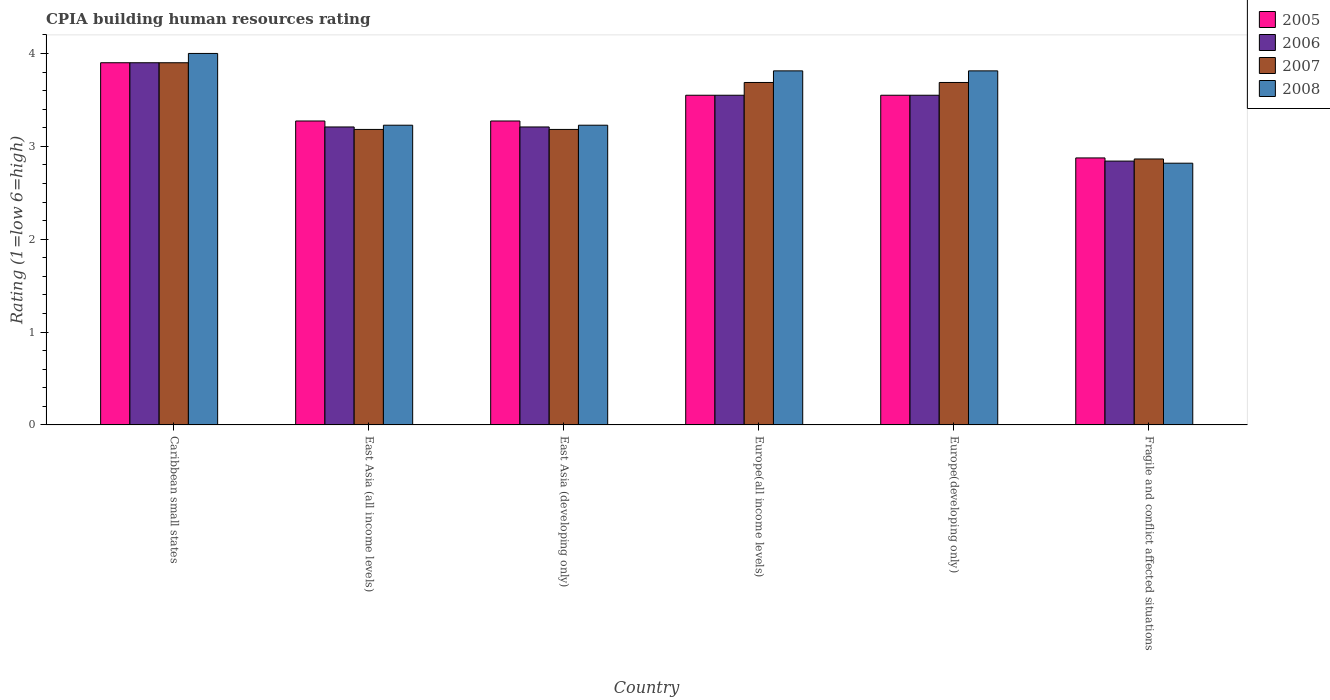Are the number of bars per tick equal to the number of legend labels?
Provide a succinct answer. Yes. Are the number of bars on each tick of the X-axis equal?
Provide a short and direct response. Yes. What is the label of the 6th group of bars from the left?
Give a very brief answer. Fragile and conflict affected situations. In how many cases, is the number of bars for a given country not equal to the number of legend labels?
Provide a succinct answer. 0. What is the CPIA rating in 2008 in Europe(all income levels)?
Offer a very short reply. 3.81. Across all countries, what is the minimum CPIA rating in 2005?
Make the answer very short. 2.88. In which country was the CPIA rating in 2008 maximum?
Provide a succinct answer. Caribbean small states. In which country was the CPIA rating in 2008 minimum?
Your answer should be very brief. Fragile and conflict affected situations. What is the total CPIA rating in 2006 in the graph?
Give a very brief answer. 20.26. What is the difference between the CPIA rating in 2007 in Europe(all income levels) and that in Europe(developing only)?
Your answer should be very brief. 0. What is the difference between the CPIA rating in 2006 in Europe(developing only) and the CPIA rating in 2008 in East Asia (developing only)?
Offer a terse response. 0.32. What is the average CPIA rating in 2007 per country?
Ensure brevity in your answer.  3.42. What is the difference between the CPIA rating of/in 2007 and CPIA rating of/in 2008 in Fragile and conflict affected situations?
Keep it short and to the point. 0.05. What is the ratio of the CPIA rating in 2008 in Caribbean small states to that in Fragile and conflict affected situations?
Give a very brief answer. 1.42. What is the difference between the highest and the second highest CPIA rating in 2007?
Provide a short and direct response. -0.21. What is the difference between the highest and the lowest CPIA rating in 2006?
Offer a terse response. 1.06. In how many countries, is the CPIA rating in 2007 greater than the average CPIA rating in 2007 taken over all countries?
Offer a terse response. 3. Is the sum of the CPIA rating in 2005 in Caribbean small states and Europe(all income levels) greater than the maximum CPIA rating in 2006 across all countries?
Your answer should be very brief. Yes. What does the 1st bar from the left in Europe(all income levels) represents?
Keep it short and to the point. 2005. Is it the case that in every country, the sum of the CPIA rating in 2006 and CPIA rating in 2008 is greater than the CPIA rating in 2005?
Make the answer very short. Yes. How many countries are there in the graph?
Give a very brief answer. 6. How are the legend labels stacked?
Your answer should be very brief. Vertical. What is the title of the graph?
Your response must be concise. CPIA building human resources rating. What is the label or title of the Y-axis?
Make the answer very short. Rating (1=low 6=high). What is the Rating (1=low 6=high) in 2005 in East Asia (all income levels)?
Make the answer very short. 3.27. What is the Rating (1=low 6=high) in 2006 in East Asia (all income levels)?
Your answer should be compact. 3.21. What is the Rating (1=low 6=high) of 2007 in East Asia (all income levels)?
Your response must be concise. 3.18. What is the Rating (1=low 6=high) of 2008 in East Asia (all income levels)?
Your answer should be compact. 3.23. What is the Rating (1=low 6=high) in 2005 in East Asia (developing only)?
Your answer should be compact. 3.27. What is the Rating (1=low 6=high) in 2006 in East Asia (developing only)?
Keep it short and to the point. 3.21. What is the Rating (1=low 6=high) of 2007 in East Asia (developing only)?
Ensure brevity in your answer.  3.18. What is the Rating (1=low 6=high) in 2008 in East Asia (developing only)?
Offer a very short reply. 3.23. What is the Rating (1=low 6=high) of 2005 in Europe(all income levels)?
Offer a terse response. 3.55. What is the Rating (1=low 6=high) of 2006 in Europe(all income levels)?
Provide a short and direct response. 3.55. What is the Rating (1=low 6=high) of 2007 in Europe(all income levels)?
Provide a succinct answer. 3.69. What is the Rating (1=low 6=high) of 2008 in Europe(all income levels)?
Provide a succinct answer. 3.81. What is the Rating (1=low 6=high) of 2005 in Europe(developing only)?
Give a very brief answer. 3.55. What is the Rating (1=low 6=high) in 2006 in Europe(developing only)?
Offer a terse response. 3.55. What is the Rating (1=low 6=high) of 2007 in Europe(developing only)?
Your answer should be compact. 3.69. What is the Rating (1=low 6=high) of 2008 in Europe(developing only)?
Your answer should be compact. 3.81. What is the Rating (1=low 6=high) of 2005 in Fragile and conflict affected situations?
Keep it short and to the point. 2.88. What is the Rating (1=low 6=high) in 2006 in Fragile and conflict affected situations?
Offer a very short reply. 2.84. What is the Rating (1=low 6=high) of 2007 in Fragile and conflict affected situations?
Your response must be concise. 2.86. What is the Rating (1=low 6=high) of 2008 in Fragile and conflict affected situations?
Your answer should be compact. 2.82. Across all countries, what is the maximum Rating (1=low 6=high) of 2008?
Provide a succinct answer. 4. Across all countries, what is the minimum Rating (1=low 6=high) of 2005?
Give a very brief answer. 2.88. Across all countries, what is the minimum Rating (1=low 6=high) of 2006?
Your response must be concise. 2.84. Across all countries, what is the minimum Rating (1=low 6=high) of 2007?
Offer a terse response. 2.86. Across all countries, what is the minimum Rating (1=low 6=high) of 2008?
Ensure brevity in your answer.  2.82. What is the total Rating (1=low 6=high) in 2005 in the graph?
Ensure brevity in your answer.  20.42. What is the total Rating (1=low 6=high) of 2006 in the graph?
Ensure brevity in your answer.  20.26. What is the total Rating (1=low 6=high) of 2007 in the graph?
Offer a terse response. 20.5. What is the total Rating (1=low 6=high) of 2008 in the graph?
Keep it short and to the point. 20.9. What is the difference between the Rating (1=low 6=high) in 2005 in Caribbean small states and that in East Asia (all income levels)?
Make the answer very short. 0.63. What is the difference between the Rating (1=low 6=high) of 2006 in Caribbean small states and that in East Asia (all income levels)?
Offer a very short reply. 0.69. What is the difference between the Rating (1=low 6=high) in 2007 in Caribbean small states and that in East Asia (all income levels)?
Keep it short and to the point. 0.72. What is the difference between the Rating (1=low 6=high) in 2008 in Caribbean small states and that in East Asia (all income levels)?
Make the answer very short. 0.77. What is the difference between the Rating (1=low 6=high) in 2005 in Caribbean small states and that in East Asia (developing only)?
Keep it short and to the point. 0.63. What is the difference between the Rating (1=low 6=high) in 2006 in Caribbean small states and that in East Asia (developing only)?
Your answer should be compact. 0.69. What is the difference between the Rating (1=low 6=high) in 2007 in Caribbean small states and that in East Asia (developing only)?
Ensure brevity in your answer.  0.72. What is the difference between the Rating (1=low 6=high) in 2008 in Caribbean small states and that in East Asia (developing only)?
Give a very brief answer. 0.77. What is the difference between the Rating (1=low 6=high) in 2007 in Caribbean small states and that in Europe(all income levels)?
Your answer should be compact. 0.21. What is the difference between the Rating (1=low 6=high) of 2008 in Caribbean small states and that in Europe(all income levels)?
Make the answer very short. 0.19. What is the difference between the Rating (1=low 6=high) of 2007 in Caribbean small states and that in Europe(developing only)?
Offer a terse response. 0.21. What is the difference between the Rating (1=low 6=high) of 2008 in Caribbean small states and that in Europe(developing only)?
Offer a very short reply. 0.19. What is the difference between the Rating (1=low 6=high) of 2006 in Caribbean small states and that in Fragile and conflict affected situations?
Offer a terse response. 1.06. What is the difference between the Rating (1=low 6=high) of 2007 in Caribbean small states and that in Fragile and conflict affected situations?
Provide a short and direct response. 1.04. What is the difference between the Rating (1=low 6=high) in 2008 in Caribbean small states and that in Fragile and conflict affected situations?
Provide a short and direct response. 1.18. What is the difference between the Rating (1=low 6=high) in 2005 in East Asia (all income levels) and that in East Asia (developing only)?
Your answer should be very brief. 0. What is the difference between the Rating (1=low 6=high) in 2006 in East Asia (all income levels) and that in East Asia (developing only)?
Your answer should be compact. 0. What is the difference between the Rating (1=low 6=high) of 2007 in East Asia (all income levels) and that in East Asia (developing only)?
Provide a succinct answer. 0. What is the difference between the Rating (1=low 6=high) in 2008 in East Asia (all income levels) and that in East Asia (developing only)?
Make the answer very short. 0. What is the difference between the Rating (1=low 6=high) in 2005 in East Asia (all income levels) and that in Europe(all income levels)?
Offer a very short reply. -0.28. What is the difference between the Rating (1=low 6=high) in 2006 in East Asia (all income levels) and that in Europe(all income levels)?
Keep it short and to the point. -0.34. What is the difference between the Rating (1=low 6=high) in 2007 in East Asia (all income levels) and that in Europe(all income levels)?
Offer a terse response. -0.51. What is the difference between the Rating (1=low 6=high) of 2008 in East Asia (all income levels) and that in Europe(all income levels)?
Provide a short and direct response. -0.59. What is the difference between the Rating (1=low 6=high) of 2005 in East Asia (all income levels) and that in Europe(developing only)?
Your answer should be compact. -0.28. What is the difference between the Rating (1=low 6=high) of 2006 in East Asia (all income levels) and that in Europe(developing only)?
Ensure brevity in your answer.  -0.34. What is the difference between the Rating (1=low 6=high) of 2007 in East Asia (all income levels) and that in Europe(developing only)?
Your answer should be very brief. -0.51. What is the difference between the Rating (1=low 6=high) of 2008 in East Asia (all income levels) and that in Europe(developing only)?
Provide a succinct answer. -0.59. What is the difference between the Rating (1=low 6=high) of 2005 in East Asia (all income levels) and that in Fragile and conflict affected situations?
Offer a terse response. 0.4. What is the difference between the Rating (1=low 6=high) in 2006 in East Asia (all income levels) and that in Fragile and conflict affected situations?
Give a very brief answer. 0.37. What is the difference between the Rating (1=low 6=high) of 2007 in East Asia (all income levels) and that in Fragile and conflict affected situations?
Make the answer very short. 0.32. What is the difference between the Rating (1=low 6=high) in 2008 in East Asia (all income levels) and that in Fragile and conflict affected situations?
Ensure brevity in your answer.  0.41. What is the difference between the Rating (1=low 6=high) of 2005 in East Asia (developing only) and that in Europe(all income levels)?
Offer a terse response. -0.28. What is the difference between the Rating (1=low 6=high) in 2006 in East Asia (developing only) and that in Europe(all income levels)?
Offer a terse response. -0.34. What is the difference between the Rating (1=low 6=high) in 2007 in East Asia (developing only) and that in Europe(all income levels)?
Keep it short and to the point. -0.51. What is the difference between the Rating (1=low 6=high) in 2008 in East Asia (developing only) and that in Europe(all income levels)?
Your response must be concise. -0.59. What is the difference between the Rating (1=low 6=high) of 2005 in East Asia (developing only) and that in Europe(developing only)?
Give a very brief answer. -0.28. What is the difference between the Rating (1=low 6=high) in 2006 in East Asia (developing only) and that in Europe(developing only)?
Your answer should be very brief. -0.34. What is the difference between the Rating (1=low 6=high) in 2007 in East Asia (developing only) and that in Europe(developing only)?
Make the answer very short. -0.51. What is the difference between the Rating (1=low 6=high) of 2008 in East Asia (developing only) and that in Europe(developing only)?
Give a very brief answer. -0.59. What is the difference between the Rating (1=low 6=high) of 2005 in East Asia (developing only) and that in Fragile and conflict affected situations?
Provide a short and direct response. 0.4. What is the difference between the Rating (1=low 6=high) in 2006 in East Asia (developing only) and that in Fragile and conflict affected situations?
Your answer should be compact. 0.37. What is the difference between the Rating (1=low 6=high) in 2007 in East Asia (developing only) and that in Fragile and conflict affected situations?
Your response must be concise. 0.32. What is the difference between the Rating (1=low 6=high) in 2008 in East Asia (developing only) and that in Fragile and conflict affected situations?
Ensure brevity in your answer.  0.41. What is the difference between the Rating (1=low 6=high) of 2005 in Europe(all income levels) and that in Fragile and conflict affected situations?
Provide a succinct answer. 0.68. What is the difference between the Rating (1=low 6=high) in 2006 in Europe(all income levels) and that in Fragile and conflict affected situations?
Ensure brevity in your answer.  0.71. What is the difference between the Rating (1=low 6=high) of 2007 in Europe(all income levels) and that in Fragile and conflict affected situations?
Ensure brevity in your answer.  0.82. What is the difference between the Rating (1=low 6=high) in 2005 in Europe(developing only) and that in Fragile and conflict affected situations?
Ensure brevity in your answer.  0.68. What is the difference between the Rating (1=low 6=high) in 2006 in Europe(developing only) and that in Fragile and conflict affected situations?
Your answer should be compact. 0.71. What is the difference between the Rating (1=low 6=high) of 2007 in Europe(developing only) and that in Fragile and conflict affected situations?
Make the answer very short. 0.82. What is the difference between the Rating (1=low 6=high) of 2008 in Europe(developing only) and that in Fragile and conflict affected situations?
Make the answer very short. 0.99. What is the difference between the Rating (1=low 6=high) in 2005 in Caribbean small states and the Rating (1=low 6=high) in 2006 in East Asia (all income levels)?
Ensure brevity in your answer.  0.69. What is the difference between the Rating (1=low 6=high) of 2005 in Caribbean small states and the Rating (1=low 6=high) of 2007 in East Asia (all income levels)?
Ensure brevity in your answer.  0.72. What is the difference between the Rating (1=low 6=high) in 2005 in Caribbean small states and the Rating (1=low 6=high) in 2008 in East Asia (all income levels)?
Provide a succinct answer. 0.67. What is the difference between the Rating (1=low 6=high) of 2006 in Caribbean small states and the Rating (1=low 6=high) of 2007 in East Asia (all income levels)?
Offer a terse response. 0.72. What is the difference between the Rating (1=low 6=high) in 2006 in Caribbean small states and the Rating (1=low 6=high) in 2008 in East Asia (all income levels)?
Offer a terse response. 0.67. What is the difference between the Rating (1=low 6=high) of 2007 in Caribbean small states and the Rating (1=low 6=high) of 2008 in East Asia (all income levels)?
Ensure brevity in your answer.  0.67. What is the difference between the Rating (1=low 6=high) in 2005 in Caribbean small states and the Rating (1=low 6=high) in 2006 in East Asia (developing only)?
Ensure brevity in your answer.  0.69. What is the difference between the Rating (1=low 6=high) of 2005 in Caribbean small states and the Rating (1=low 6=high) of 2007 in East Asia (developing only)?
Provide a succinct answer. 0.72. What is the difference between the Rating (1=low 6=high) in 2005 in Caribbean small states and the Rating (1=low 6=high) in 2008 in East Asia (developing only)?
Give a very brief answer. 0.67. What is the difference between the Rating (1=low 6=high) in 2006 in Caribbean small states and the Rating (1=low 6=high) in 2007 in East Asia (developing only)?
Make the answer very short. 0.72. What is the difference between the Rating (1=low 6=high) in 2006 in Caribbean small states and the Rating (1=low 6=high) in 2008 in East Asia (developing only)?
Offer a very short reply. 0.67. What is the difference between the Rating (1=low 6=high) in 2007 in Caribbean small states and the Rating (1=low 6=high) in 2008 in East Asia (developing only)?
Your answer should be compact. 0.67. What is the difference between the Rating (1=low 6=high) of 2005 in Caribbean small states and the Rating (1=low 6=high) of 2006 in Europe(all income levels)?
Make the answer very short. 0.35. What is the difference between the Rating (1=low 6=high) of 2005 in Caribbean small states and the Rating (1=low 6=high) of 2007 in Europe(all income levels)?
Keep it short and to the point. 0.21. What is the difference between the Rating (1=low 6=high) of 2005 in Caribbean small states and the Rating (1=low 6=high) of 2008 in Europe(all income levels)?
Provide a short and direct response. 0.09. What is the difference between the Rating (1=low 6=high) in 2006 in Caribbean small states and the Rating (1=low 6=high) in 2007 in Europe(all income levels)?
Provide a succinct answer. 0.21. What is the difference between the Rating (1=low 6=high) in 2006 in Caribbean small states and the Rating (1=low 6=high) in 2008 in Europe(all income levels)?
Your response must be concise. 0.09. What is the difference between the Rating (1=low 6=high) of 2007 in Caribbean small states and the Rating (1=low 6=high) of 2008 in Europe(all income levels)?
Keep it short and to the point. 0.09. What is the difference between the Rating (1=low 6=high) of 2005 in Caribbean small states and the Rating (1=low 6=high) of 2006 in Europe(developing only)?
Make the answer very short. 0.35. What is the difference between the Rating (1=low 6=high) in 2005 in Caribbean small states and the Rating (1=low 6=high) in 2007 in Europe(developing only)?
Keep it short and to the point. 0.21. What is the difference between the Rating (1=low 6=high) in 2005 in Caribbean small states and the Rating (1=low 6=high) in 2008 in Europe(developing only)?
Offer a very short reply. 0.09. What is the difference between the Rating (1=low 6=high) in 2006 in Caribbean small states and the Rating (1=low 6=high) in 2007 in Europe(developing only)?
Your response must be concise. 0.21. What is the difference between the Rating (1=low 6=high) of 2006 in Caribbean small states and the Rating (1=low 6=high) of 2008 in Europe(developing only)?
Your answer should be very brief. 0.09. What is the difference between the Rating (1=low 6=high) in 2007 in Caribbean small states and the Rating (1=low 6=high) in 2008 in Europe(developing only)?
Ensure brevity in your answer.  0.09. What is the difference between the Rating (1=low 6=high) in 2005 in Caribbean small states and the Rating (1=low 6=high) in 2006 in Fragile and conflict affected situations?
Provide a short and direct response. 1.06. What is the difference between the Rating (1=low 6=high) in 2005 in Caribbean small states and the Rating (1=low 6=high) in 2007 in Fragile and conflict affected situations?
Provide a short and direct response. 1.04. What is the difference between the Rating (1=low 6=high) of 2005 in Caribbean small states and the Rating (1=low 6=high) of 2008 in Fragile and conflict affected situations?
Offer a very short reply. 1.08. What is the difference between the Rating (1=low 6=high) in 2006 in Caribbean small states and the Rating (1=low 6=high) in 2007 in Fragile and conflict affected situations?
Give a very brief answer. 1.04. What is the difference between the Rating (1=low 6=high) of 2006 in Caribbean small states and the Rating (1=low 6=high) of 2008 in Fragile and conflict affected situations?
Make the answer very short. 1.08. What is the difference between the Rating (1=low 6=high) of 2007 in Caribbean small states and the Rating (1=low 6=high) of 2008 in Fragile and conflict affected situations?
Your response must be concise. 1.08. What is the difference between the Rating (1=low 6=high) of 2005 in East Asia (all income levels) and the Rating (1=low 6=high) of 2006 in East Asia (developing only)?
Keep it short and to the point. 0.06. What is the difference between the Rating (1=low 6=high) in 2005 in East Asia (all income levels) and the Rating (1=low 6=high) in 2007 in East Asia (developing only)?
Your response must be concise. 0.09. What is the difference between the Rating (1=low 6=high) of 2005 in East Asia (all income levels) and the Rating (1=low 6=high) of 2008 in East Asia (developing only)?
Give a very brief answer. 0.05. What is the difference between the Rating (1=low 6=high) in 2006 in East Asia (all income levels) and the Rating (1=low 6=high) in 2007 in East Asia (developing only)?
Ensure brevity in your answer.  0.03. What is the difference between the Rating (1=low 6=high) of 2006 in East Asia (all income levels) and the Rating (1=low 6=high) of 2008 in East Asia (developing only)?
Give a very brief answer. -0.02. What is the difference between the Rating (1=low 6=high) of 2007 in East Asia (all income levels) and the Rating (1=low 6=high) of 2008 in East Asia (developing only)?
Ensure brevity in your answer.  -0.05. What is the difference between the Rating (1=low 6=high) of 2005 in East Asia (all income levels) and the Rating (1=low 6=high) of 2006 in Europe(all income levels)?
Provide a succinct answer. -0.28. What is the difference between the Rating (1=low 6=high) in 2005 in East Asia (all income levels) and the Rating (1=low 6=high) in 2007 in Europe(all income levels)?
Provide a short and direct response. -0.41. What is the difference between the Rating (1=low 6=high) of 2005 in East Asia (all income levels) and the Rating (1=low 6=high) of 2008 in Europe(all income levels)?
Offer a terse response. -0.54. What is the difference between the Rating (1=low 6=high) of 2006 in East Asia (all income levels) and the Rating (1=low 6=high) of 2007 in Europe(all income levels)?
Keep it short and to the point. -0.48. What is the difference between the Rating (1=low 6=high) of 2006 in East Asia (all income levels) and the Rating (1=low 6=high) of 2008 in Europe(all income levels)?
Your response must be concise. -0.6. What is the difference between the Rating (1=low 6=high) in 2007 in East Asia (all income levels) and the Rating (1=low 6=high) in 2008 in Europe(all income levels)?
Keep it short and to the point. -0.63. What is the difference between the Rating (1=low 6=high) in 2005 in East Asia (all income levels) and the Rating (1=low 6=high) in 2006 in Europe(developing only)?
Provide a succinct answer. -0.28. What is the difference between the Rating (1=low 6=high) of 2005 in East Asia (all income levels) and the Rating (1=low 6=high) of 2007 in Europe(developing only)?
Give a very brief answer. -0.41. What is the difference between the Rating (1=low 6=high) of 2005 in East Asia (all income levels) and the Rating (1=low 6=high) of 2008 in Europe(developing only)?
Your answer should be compact. -0.54. What is the difference between the Rating (1=low 6=high) in 2006 in East Asia (all income levels) and the Rating (1=low 6=high) in 2007 in Europe(developing only)?
Provide a succinct answer. -0.48. What is the difference between the Rating (1=low 6=high) of 2006 in East Asia (all income levels) and the Rating (1=low 6=high) of 2008 in Europe(developing only)?
Keep it short and to the point. -0.6. What is the difference between the Rating (1=low 6=high) in 2007 in East Asia (all income levels) and the Rating (1=low 6=high) in 2008 in Europe(developing only)?
Ensure brevity in your answer.  -0.63. What is the difference between the Rating (1=low 6=high) in 2005 in East Asia (all income levels) and the Rating (1=low 6=high) in 2006 in Fragile and conflict affected situations?
Make the answer very short. 0.43. What is the difference between the Rating (1=low 6=high) in 2005 in East Asia (all income levels) and the Rating (1=low 6=high) in 2007 in Fragile and conflict affected situations?
Provide a succinct answer. 0.41. What is the difference between the Rating (1=low 6=high) in 2005 in East Asia (all income levels) and the Rating (1=low 6=high) in 2008 in Fragile and conflict affected situations?
Give a very brief answer. 0.45. What is the difference between the Rating (1=low 6=high) in 2006 in East Asia (all income levels) and the Rating (1=low 6=high) in 2007 in Fragile and conflict affected situations?
Ensure brevity in your answer.  0.34. What is the difference between the Rating (1=low 6=high) in 2006 in East Asia (all income levels) and the Rating (1=low 6=high) in 2008 in Fragile and conflict affected situations?
Offer a terse response. 0.39. What is the difference between the Rating (1=low 6=high) of 2007 in East Asia (all income levels) and the Rating (1=low 6=high) of 2008 in Fragile and conflict affected situations?
Your response must be concise. 0.36. What is the difference between the Rating (1=low 6=high) of 2005 in East Asia (developing only) and the Rating (1=low 6=high) of 2006 in Europe(all income levels)?
Provide a short and direct response. -0.28. What is the difference between the Rating (1=low 6=high) of 2005 in East Asia (developing only) and the Rating (1=low 6=high) of 2007 in Europe(all income levels)?
Your answer should be compact. -0.41. What is the difference between the Rating (1=low 6=high) in 2005 in East Asia (developing only) and the Rating (1=low 6=high) in 2008 in Europe(all income levels)?
Give a very brief answer. -0.54. What is the difference between the Rating (1=low 6=high) in 2006 in East Asia (developing only) and the Rating (1=low 6=high) in 2007 in Europe(all income levels)?
Your answer should be very brief. -0.48. What is the difference between the Rating (1=low 6=high) in 2006 in East Asia (developing only) and the Rating (1=low 6=high) in 2008 in Europe(all income levels)?
Ensure brevity in your answer.  -0.6. What is the difference between the Rating (1=low 6=high) of 2007 in East Asia (developing only) and the Rating (1=low 6=high) of 2008 in Europe(all income levels)?
Provide a succinct answer. -0.63. What is the difference between the Rating (1=low 6=high) in 2005 in East Asia (developing only) and the Rating (1=low 6=high) in 2006 in Europe(developing only)?
Your answer should be very brief. -0.28. What is the difference between the Rating (1=low 6=high) of 2005 in East Asia (developing only) and the Rating (1=low 6=high) of 2007 in Europe(developing only)?
Provide a short and direct response. -0.41. What is the difference between the Rating (1=low 6=high) of 2005 in East Asia (developing only) and the Rating (1=low 6=high) of 2008 in Europe(developing only)?
Make the answer very short. -0.54. What is the difference between the Rating (1=low 6=high) in 2006 in East Asia (developing only) and the Rating (1=low 6=high) in 2007 in Europe(developing only)?
Offer a very short reply. -0.48. What is the difference between the Rating (1=low 6=high) of 2006 in East Asia (developing only) and the Rating (1=low 6=high) of 2008 in Europe(developing only)?
Provide a short and direct response. -0.6. What is the difference between the Rating (1=low 6=high) of 2007 in East Asia (developing only) and the Rating (1=low 6=high) of 2008 in Europe(developing only)?
Offer a very short reply. -0.63. What is the difference between the Rating (1=low 6=high) in 2005 in East Asia (developing only) and the Rating (1=low 6=high) in 2006 in Fragile and conflict affected situations?
Your answer should be compact. 0.43. What is the difference between the Rating (1=low 6=high) of 2005 in East Asia (developing only) and the Rating (1=low 6=high) of 2007 in Fragile and conflict affected situations?
Provide a short and direct response. 0.41. What is the difference between the Rating (1=low 6=high) of 2005 in East Asia (developing only) and the Rating (1=low 6=high) of 2008 in Fragile and conflict affected situations?
Your answer should be compact. 0.45. What is the difference between the Rating (1=low 6=high) in 2006 in East Asia (developing only) and the Rating (1=low 6=high) in 2007 in Fragile and conflict affected situations?
Keep it short and to the point. 0.34. What is the difference between the Rating (1=low 6=high) of 2006 in East Asia (developing only) and the Rating (1=low 6=high) of 2008 in Fragile and conflict affected situations?
Your answer should be compact. 0.39. What is the difference between the Rating (1=low 6=high) of 2007 in East Asia (developing only) and the Rating (1=low 6=high) of 2008 in Fragile and conflict affected situations?
Make the answer very short. 0.36. What is the difference between the Rating (1=low 6=high) of 2005 in Europe(all income levels) and the Rating (1=low 6=high) of 2007 in Europe(developing only)?
Ensure brevity in your answer.  -0.14. What is the difference between the Rating (1=low 6=high) in 2005 in Europe(all income levels) and the Rating (1=low 6=high) in 2008 in Europe(developing only)?
Offer a terse response. -0.26. What is the difference between the Rating (1=low 6=high) of 2006 in Europe(all income levels) and the Rating (1=low 6=high) of 2007 in Europe(developing only)?
Make the answer very short. -0.14. What is the difference between the Rating (1=low 6=high) in 2006 in Europe(all income levels) and the Rating (1=low 6=high) in 2008 in Europe(developing only)?
Keep it short and to the point. -0.26. What is the difference between the Rating (1=low 6=high) in 2007 in Europe(all income levels) and the Rating (1=low 6=high) in 2008 in Europe(developing only)?
Keep it short and to the point. -0.12. What is the difference between the Rating (1=low 6=high) in 2005 in Europe(all income levels) and the Rating (1=low 6=high) in 2006 in Fragile and conflict affected situations?
Make the answer very short. 0.71. What is the difference between the Rating (1=low 6=high) of 2005 in Europe(all income levels) and the Rating (1=low 6=high) of 2007 in Fragile and conflict affected situations?
Give a very brief answer. 0.69. What is the difference between the Rating (1=low 6=high) in 2005 in Europe(all income levels) and the Rating (1=low 6=high) in 2008 in Fragile and conflict affected situations?
Give a very brief answer. 0.73. What is the difference between the Rating (1=low 6=high) in 2006 in Europe(all income levels) and the Rating (1=low 6=high) in 2007 in Fragile and conflict affected situations?
Offer a terse response. 0.69. What is the difference between the Rating (1=low 6=high) of 2006 in Europe(all income levels) and the Rating (1=low 6=high) of 2008 in Fragile and conflict affected situations?
Give a very brief answer. 0.73. What is the difference between the Rating (1=low 6=high) in 2007 in Europe(all income levels) and the Rating (1=low 6=high) in 2008 in Fragile and conflict affected situations?
Make the answer very short. 0.87. What is the difference between the Rating (1=low 6=high) in 2005 in Europe(developing only) and the Rating (1=low 6=high) in 2006 in Fragile and conflict affected situations?
Ensure brevity in your answer.  0.71. What is the difference between the Rating (1=low 6=high) of 2005 in Europe(developing only) and the Rating (1=low 6=high) of 2007 in Fragile and conflict affected situations?
Ensure brevity in your answer.  0.69. What is the difference between the Rating (1=low 6=high) in 2005 in Europe(developing only) and the Rating (1=low 6=high) in 2008 in Fragile and conflict affected situations?
Keep it short and to the point. 0.73. What is the difference between the Rating (1=low 6=high) in 2006 in Europe(developing only) and the Rating (1=low 6=high) in 2007 in Fragile and conflict affected situations?
Provide a short and direct response. 0.69. What is the difference between the Rating (1=low 6=high) of 2006 in Europe(developing only) and the Rating (1=low 6=high) of 2008 in Fragile and conflict affected situations?
Give a very brief answer. 0.73. What is the difference between the Rating (1=low 6=high) in 2007 in Europe(developing only) and the Rating (1=low 6=high) in 2008 in Fragile and conflict affected situations?
Your answer should be very brief. 0.87. What is the average Rating (1=low 6=high) in 2005 per country?
Your response must be concise. 3.4. What is the average Rating (1=low 6=high) of 2006 per country?
Your response must be concise. 3.38. What is the average Rating (1=low 6=high) of 2007 per country?
Ensure brevity in your answer.  3.42. What is the average Rating (1=low 6=high) of 2008 per country?
Your response must be concise. 3.48. What is the difference between the Rating (1=low 6=high) of 2005 and Rating (1=low 6=high) of 2007 in Caribbean small states?
Ensure brevity in your answer.  0. What is the difference between the Rating (1=low 6=high) of 2006 and Rating (1=low 6=high) of 2007 in Caribbean small states?
Keep it short and to the point. 0. What is the difference between the Rating (1=low 6=high) of 2006 and Rating (1=low 6=high) of 2008 in Caribbean small states?
Give a very brief answer. -0.1. What is the difference between the Rating (1=low 6=high) of 2007 and Rating (1=low 6=high) of 2008 in Caribbean small states?
Make the answer very short. -0.1. What is the difference between the Rating (1=low 6=high) of 2005 and Rating (1=low 6=high) of 2006 in East Asia (all income levels)?
Keep it short and to the point. 0.06. What is the difference between the Rating (1=low 6=high) in 2005 and Rating (1=low 6=high) in 2007 in East Asia (all income levels)?
Offer a terse response. 0.09. What is the difference between the Rating (1=low 6=high) of 2005 and Rating (1=low 6=high) of 2008 in East Asia (all income levels)?
Provide a succinct answer. 0.05. What is the difference between the Rating (1=low 6=high) of 2006 and Rating (1=low 6=high) of 2007 in East Asia (all income levels)?
Provide a succinct answer. 0.03. What is the difference between the Rating (1=low 6=high) of 2006 and Rating (1=low 6=high) of 2008 in East Asia (all income levels)?
Your answer should be compact. -0.02. What is the difference between the Rating (1=low 6=high) of 2007 and Rating (1=low 6=high) of 2008 in East Asia (all income levels)?
Make the answer very short. -0.05. What is the difference between the Rating (1=low 6=high) of 2005 and Rating (1=low 6=high) of 2006 in East Asia (developing only)?
Keep it short and to the point. 0.06. What is the difference between the Rating (1=low 6=high) in 2005 and Rating (1=low 6=high) in 2007 in East Asia (developing only)?
Keep it short and to the point. 0.09. What is the difference between the Rating (1=low 6=high) in 2005 and Rating (1=low 6=high) in 2008 in East Asia (developing only)?
Make the answer very short. 0.05. What is the difference between the Rating (1=low 6=high) in 2006 and Rating (1=low 6=high) in 2007 in East Asia (developing only)?
Provide a succinct answer. 0.03. What is the difference between the Rating (1=low 6=high) in 2006 and Rating (1=low 6=high) in 2008 in East Asia (developing only)?
Offer a very short reply. -0.02. What is the difference between the Rating (1=low 6=high) of 2007 and Rating (1=low 6=high) of 2008 in East Asia (developing only)?
Your response must be concise. -0.05. What is the difference between the Rating (1=low 6=high) in 2005 and Rating (1=low 6=high) in 2006 in Europe(all income levels)?
Make the answer very short. 0. What is the difference between the Rating (1=low 6=high) in 2005 and Rating (1=low 6=high) in 2007 in Europe(all income levels)?
Your answer should be very brief. -0.14. What is the difference between the Rating (1=low 6=high) in 2005 and Rating (1=low 6=high) in 2008 in Europe(all income levels)?
Ensure brevity in your answer.  -0.26. What is the difference between the Rating (1=low 6=high) of 2006 and Rating (1=low 6=high) of 2007 in Europe(all income levels)?
Give a very brief answer. -0.14. What is the difference between the Rating (1=low 6=high) in 2006 and Rating (1=low 6=high) in 2008 in Europe(all income levels)?
Make the answer very short. -0.26. What is the difference between the Rating (1=low 6=high) in 2007 and Rating (1=low 6=high) in 2008 in Europe(all income levels)?
Ensure brevity in your answer.  -0.12. What is the difference between the Rating (1=low 6=high) of 2005 and Rating (1=low 6=high) of 2006 in Europe(developing only)?
Give a very brief answer. 0. What is the difference between the Rating (1=low 6=high) of 2005 and Rating (1=low 6=high) of 2007 in Europe(developing only)?
Make the answer very short. -0.14. What is the difference between the Rating (1=low 6=high) in 2005 and Rating (1=low 6=high) in 2008 in Europe(developing only)?
Give a very brief answer. -0.26. What is the difference between the Rating (1=low 6=high) in 2006 and Rating (1=low 6=high) in 2007 in Europe(developing only)?
Ensure brevity in your answer.  -0.14. What is the difference between the Rating (1=low 6=high) of 2006 and Rating (1=low 6=high) of 2008 in Europe(developing only)?
Provide a succinct answer. -0.26. What is the difference between the Rating (1=low 6=high) in 2007 and Rating (1=low 6=high) in 2008 in Europe(developing only)?
Ensure brevity in your answer.  -0.12. What is the difference between the Rating (1=low 6=high) in 2005 and Rating (1=low 6=high) in 2006 in Fragile and conflict affected situations?
Provide a short and direct response. 0.03. What is the difference between the Rating (1=low 6=high) of 2005 and Rating (1=low 6=high) of 2007 in Fragile and conflict affected situations?
Keep it short and to the point. 0.01. What is the difference between the Rating (1=low 6=high) of 2005 and Rating (1=low 6=high) of 2008 in Fragile and conflict affected situations?
Give a very brief answer. 0.06. What is the difference between the Rating (1=low 6=high) in 2006 and Rating (1=low 6=high) in 2007 in Fragile and conflict affected situations?
Ensure brevity in your answer.  -0.02. What is the difference between the Rating (1=low 6=high) of 2006 and Rating (1=low 6=high) of 2008 in Fragile and conflict affected situations?
Your answer should be very brief. 0.02. What is the difference between the Rating (1=low 6=high) in 2007 and Rating (1=low 6=high) in 2008 in Fragile and conflict affected situations?
Ensure brevity in your answer.  0.05. What is the ratio of the Rating (1=low 6=high) in 2005 in Caribbean small states to that in East Asia (all income levels)?
Keep it short and to the point. 1.19. What is the ratio of the Rating (1=low 6=high) in 2006 in Caribbean small states to that in East Asia (all income levels)?
Make the answer very short. 1.22. What is the ratio of the Rating (1=low 6=high) of 2007 in Caribbean small states to that in East Asia (all income levels)?
Offer a very short reply. 1.23. What is the ratio of the Rating (1=low 6=high) of 2008 in Caribbean small states to that in East Asia (all income levels)?
Ensure brevity in your answer.  1.24. What is the ratio of the Rating (1=low 6=high) in 2005 in Caribbean small states to that in East Asia (developing only)?
Give a very brief answer. 1.19. What is the ratio of the Rating (1=low 6=high) in 2006 in Caribbean small states to that in East Asia (developing only)?
Your answer should be compact. 1.22. What is the ratio of the Rating (1=low 6=high) of 2007 in Caribbean small states to that in East Asia (developing only)?
Your response must be concise. 1.23. What is the ratio of the Rating (1=low 6=high) of 2008 in Caribbean small states to that in East Asia (developing only)?
Your answer should be very brief. 1.24. What is the ratio of the Rating (1=low 6=high) of 2005 in Caribbean small states to that in Europe(all income levels)?
Offer a very short reply. 1.1. What is the ratio of the Rating (1=low 6=high) in 2006 in Caribbean small states to that in Europe(all income levels)?
Offer a terse response. 1.1. What is the ratio of the Rating (1=low 6=high) in 2007 in Caribbean small states to that in Europe(all income levels)?
Offer a very short reply. 1.06. What is the ratio of the Rating (1=low 6=high) in 2008 in Caribbean small states to that in Europe(all income levels)?
Ensure brevity in your answer.  1.05. What is the ratio of the Rating (1=low 6=high) of 2005 in Caribbean small states to that in Europe(developing only)?
Ensure brevity in your answer.  1.1. What is the ratio of the Rating (1=low 6=high) of 2006 in Caribbean small states to that in Europe(developing only)?
Provide a short and direct response. 1.1. What is the ratio of the Rating (1=low 6=high) in 2007 in Caribbean small states to that in Europe(developing only)?
Your response must be concise. 1.06. What is the ratio of the Rating (1=low 6=high) of 2008 in Caribbean small states to that in Europe(developing only)?
Keep it short and to the point. 1.05. What is the ratio of the Rating (1=low 6=high) of 2005 in Caribbean small states to that in Fragile and conflict affected situations?
Your response must be concise. 1.36. What is the ratio of the Rating (1=low 6=high) of 2006 in Caribbean small states to that in Fragile and conflict affected situations?
Provide a short and direct response. 1.37. What is the ratio of the Rating (1=low 6=high) in 2007 in Caribbean small states to that in Fragile and conflict affected situations?
Your response must be concise. 1.36. What is the ratio of the Rating (1=low 6=high) in 2008 in Caribbean small states to that in Fragile and conflict affected situations?
Keep it short and to the point. 1.42. What is the ratio of the Rating (1=low 6=high) in 2005 in East Asia (all income levels) to that in East Asia (developing only)?
Give a very brief answer. 1. What is the ratio of the Rating (1=low 6=high) of 2008 in East Asia (all income levels) to that in East Asia (developing only)?
Make the answer very short. 1. What is the ratio of the Rating (1=low 6=high) in 2005 in East Asia (all income levels) to that in Europe(all income levels)?
Make the answer very short. 0.92. What is the ratio of the Rating (1=low 6=high) of 2006 in East Asia (all income levels) to that in Europe(all income levels)?
Your answer should be very brief. 0.9. What is the ratio of the Rating (1=low 6=high) of 2007 in East Asia (all income levels) to that in Europe(all income levels)?
Offer a very short reply. 0.86. What is the ratio of the Rating (1=low 6=high) in 2008 in East Asia (all income levels) to that in Europe(all income levels)?
Your answer should be compact. 0.85. What is the ratio of the Rating (1=low 6=high) of 2005 in East Asia (all income levels) to that in Europe(developing only)?
Keep it short and to the point. 0.92. What is the ratio of the Rating (1=low 6=high) of 2006 in East Asia (all income levels) to that in Europe(developing only)?
Provide a succinct answer. 0.9. What is the ratio of the Rating (1=low 6=high) in 2007 in East Asia (all income levels) to that in Europe(developing only)?
Offer a terse response. 0.86. What is the ratio of the Rating (1=low 6=high) in 2008 in East Asia (all income levels) to that in Europe(developing only)?
Ensure brevity in your answer.  0.85. What is the ratio of the Rating (1=low 6=high) in 2005 in East Asia (all income levels) to that in Fragile and conflict affected situations?
Offer a very short reply. 1.14. What is the ratio of the Rating (1=low 6=high) of 2006 in East Asia (all income levels) to that in Fragile and conflict affected situations?
Keep it short and to the point. 1.13. What is the ratio of the Rating (1=low 6=high) of 2008 in East Asia (all income levels) to that in Fragile and conflict affected situations?
Give a very brief answer. 1.15. What is the ratio of the Rating (1=low 6=high) in 2005 in East Asia (developing only) to that in Europe(all income levels)?
Provide a succinct answer. 0.92. What is the ratio of the Rating (1=low 6=high) of 2006 in East Asia (developing only) to that in Europe(all income levels)?
Ensure brevity in your answer.  0.9. What is the ratio of the Rating (1=low 6=high) of 2007 in East Asia (developing only) to that in Europe(all income levels)?
Offer a very short reply. 0.86. What is the ratio of the Rating (1=low 6=high) of 2008 in East Asia (developing only) to that in Europe(all income levels)?
Provide a short and direct response. 0.85. What is the ratio of the Rating (1=low 6=high) in 2005 in East Asia (developing only) to that in Europe(developing only)?
Your response must be concise. 0.92. What is the ratio of the Rating (1=low 6=high) of 2006 in East Asia (developing only) to that in Europe(developing only)?
Provide a short and direct response. 0.9. What is the ratio of the Rating (1=low 6=high) in 2007 in East Asia (developing only) to that in Europe(developing only)?
Provide a short and direct response. 0.86. What is the ratio of the Rating (1=low 6=high) of 2008 in East Asia (developing only) to that in Europe(developing only)?
Offer a terse response. 0.85. What is the ratio of the Rating (1=low 6=high) in 2005 in East Asia (developing only) to that in Fragile and conflict affected situations?
Provide a succinct answer. 1.14. What is the ratio of the Rating (1=low 6=high) in 2006 in East Asia (developing only) to that in Fragile and conflict affected situations?
Offer a very short reply. 1.13. What is the ratio of the Rating (1=low 6=high) in 2007 in East Asia (developing only) to that in Fragile and conflict affected situations?
Give a very brief answer. 1.11. What is the ratio of the Rating (1=low 6=high) in 2008 in East Asia (developing only) to that in Fragile and conflict affected situations?
Keep it short and to the point. 1.15. What is the ratio of the Rating (1=low 6=high) of 2005 in Europe(all income levels) to that in Europe(developing only)?
Keep it short and to the point. 1. What is the ratio of the Rating (1=low 6=high) of 2007 in Europe(all income levels) to that in Europe(developing only)?
Ensure brevity in your answer.  1. What is the ratio of the Rating (1=low 6=high) of 2008 in Europe(all income levels) to that in Europe(developing only)?
Give a very brief answer. 1. What is the ratio of the Rating (1=low 6=high) in 2005 in Europe(all income levels) to that in Fragile and conflict affected situations?
Provide a short and direct response. 1.23. What is the ratio of the Rating (1=low 6=high) of 2006 in Europe(all income levels) to that in Fragile and conflict affected situations?
Give a very brief answer. 1.25. What is the ratio of the Rating (1=low 6=high) in 2007 in Europe(all income levels) to that in Fragile and conflict affected situations?
Your answer should be compact. 1.29. What is the ratio of the Rating (1=low 6=high) in 2008 in Europe(all income levels) to that in Fragile and conflict affected situations?
Provide a succinct answer. 1.35. What is the ratio of the Rating (1=low 6=high) in 2005 in Europe(developing only) to that in Fragile and conflict affected situations?
Offer a very short reply. 1.23. What is the ratio of the Rating (1=low 6=high) of 2006 in Europe(developing only) to that in Fragile and conflict affected situations?
Your answer should be compact. 1.25. What is the ratio of the Rating (1=low 6=high) in 2007 in Europe(developing only) to that in Fragile and conflict affected situations?
Provide a short and direct response. 1.29. What is the ratio of the Rating (1=low 6=high) of 2008 in Europe(developing only) to that in Fragile and conflict affected situations?
Provide a short and direct response. 1.35. What is the difference between the highest and the second highest Rating (1=low 6=high) of 2005?
Provide a short and direct response. 0.35. What is the difference between the highest and the second highest Rating (1=low 6=high) of 2006?
Your answer should be very brief. 0.35. What is the difference between the highest and the second highest Rating (1=low 6=high) in 2007?
Offer a terse response. 0.21. What is the difference between the highest and the second highest Rating (1=low 6=high) in 2008?
Provide a succinct answer. 0.19. What is the difference between the highest and the lowest Rating (1=low 6=high) in 2005?
Keep it short and to the point. 1.02. What is the difference between the highest and the lowest Rating (1=low 6=high) of 2006?
Offer a terse response. 1.06. What is the difference between the highest and the lowest Rating (1=low 6=high) in 2007?
Your answer should be very brief. 1.04. What is the difference between the highest and the lowest Rating (1=low 6=high) in 2008?
Your answer should be very brief. 1.18. 